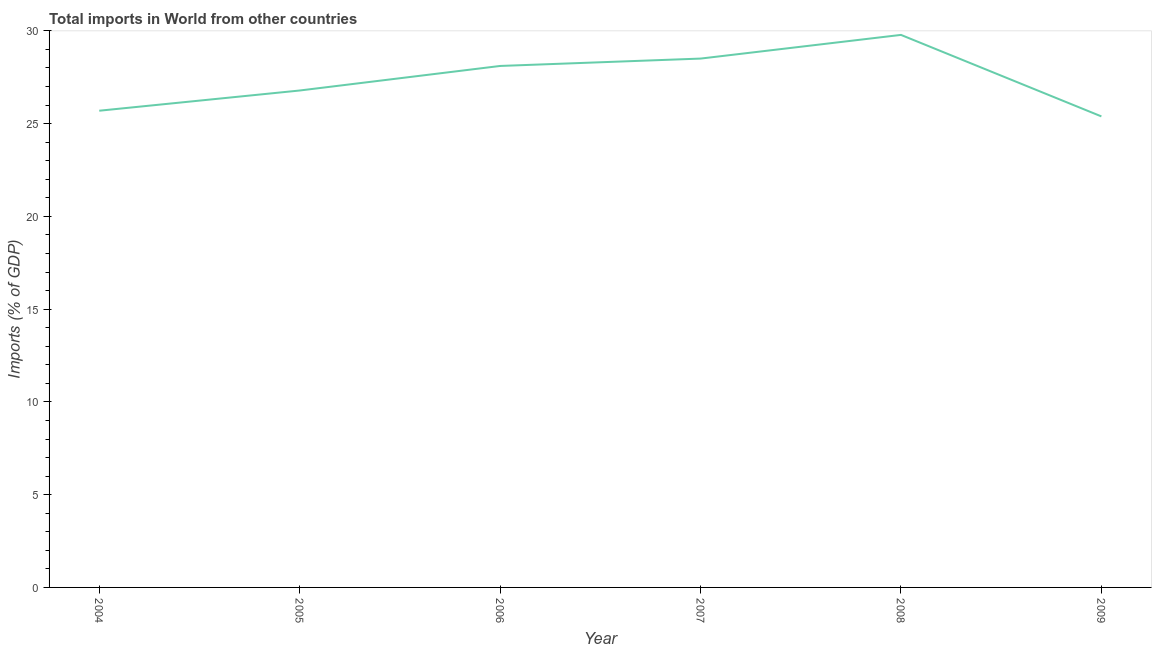What is the total imports in 2007?
Your response must be concise. 28.5. Across all years, what is the maximum total imports?
Your response must be concise. 29.78. Across all years, what is the minimum total imports?
Give a very brief answer. 25.39. In which year was the total imports minimum?
Keep it short and to the point. 2009. What is the sum of the total imports?
Make the answer very short. 164.26. What is the difference between the total imports in 2007 and 2009?
Give a very brief answer. 3.12. What is the average total imports per year?
Make the answer very short. 27.38. What is the median total imports?
Ensure brevity in your answer.  27.45. In how many years, is the total imports greater than 4 %?
Keep it short and to the point. 6. Do a majority of the years between 2007 and 2008 (inclusive) have total imports greater than 16 %?
Ensure brevity in your answer.  Yes. What is the ratio of the total imports in 2006 to that in 2008?
Your answer should be very brief. 0.94. Is the total imports in 2004 less than that in 2009?
Offer a very short reply. No. Is the difference between the total imports in 2004 and 2007 greater than the difference between any two years?
Your answer should be very brief. No. What is the difference between the highest and the second highest total imports?
Keep it short and to the point. 1.28. What is the difference between the highest and the lowest total imports?
Make the answer very short. 4.39. In how many years, is the total imports greater than the average total imports taken over all years?
Your answer should be compact. 3. How many years are there in the graph?
Provide a short and direct response. 6. Does the graph contain any zero values?
Keep it short and to the point. No. What is the title of the graph?
Keep it short and to the point. Total imports in World from other countries. What is the label or title of the X-axis?
Provide a short and direct response. Year. What is the label or title of the Y-axis?
Provide a short and direct response. Imports (% of GDP). What is the Imports (% of GDP) of 2004?
Provide a succinct answer. 25.69. What is the Imports (% of GDP) of 2005?
Give a very brief answer. 26.78. What is the Imports (% of GDP) in 2006?
Offer a very short reply. 28.11. What is the Imports (% of GDP) of 2007?
Offer a terse response. 28.5. What is the Imports (% of GDP) in 2008?
Keep it short and to the point. 29.78. What is the Imports (% of GDP) in 2009?
Ensure brevity in your answer.  25.39. What is the difference between the Imports (% of GDP) in 2004 and 2005?
Provide a short and direct response. -1.09. What is the difference between the Imports (% of GDP) in 2004 and 2006?
Offer a terse response. -2.41. What is the difference between the Imports (% of GDP) in 2004 and 2007?
Give a very brief answer. -2.81. What is the difference between the Imports (% of GDP) in 2004 and 2008?
Offer a very short reply. -4.09. What is the difference between the Imports (% of GDP) in 2004 and 2009?
Offer a terse response. 0.31. What is the difference between the Imports (% of GDP) in 2005 and 2006?
Your response must be concise. -1.32. What is the difference between the Imports (% of GDP) in 2005 and 2007?
Make the answer very short. -1.72. What is the difference between the Imports (% of GDP) in 2005 and 2008?
Offer a terse response. -3. What is the difference between the Imports (% of GDP) in 2005 and 2009?
Your response must be concise. 1.4. What is the difference between the Imports (% of GDP) in 2006 and 2007?
Give a very brief answer. -0.4. What is the difference between the Imports (% of GDP) in 2006 and 2008?
Your answer should be very brief. -1.67. What is the difference between the Imports (% of GDP) in 2006 and 2009?
Your response must be concise. 2.72. What is the difference between the Imports (% of GDP) in 2007 and 2008?
Give a very brief answer. -1.28. What is the difference between the Imports (% of GDP) in 2007 and 2009?
Offer a terse response. 3.12. What is the difference between the Imports (% of GDP) in 2008 and 2009?
Give a very brief answer. 4.39. What is the ratio of the Imports (% of GDP) in 2004 to that in 2006?
Give a very brief answer. 0.91. What is the ratio of the Imports (% of GDP) in 2004 to that in 2007?
Your answer should be compact. 0.9. What is the ratio of the Imports (% of GDP) in 2004 to that in 2008?
Your answer should be compact. 0.86. What is the ratio of the Imports (% of GDP) in 2005 to that in 2006?
Make the answer very short. 0.95. What is the ratio of the Imports (% of GDP) in 2005 to that in 2008?
Provide a short and direct response. 0.9. What is the ratio of the Imports (% of GDP) in 2005 to that in 2009?
Your answer should be compact. 1.05. What is the ratio of the Imports (% of GDP) in 2006 to that in 2008?
Keep it short and to the point. 0.94. What is the ratio of the Imports (% of GDP) in 2006 to that in 2009?
Offer a terse response. 1.11. What is the ratio of the Imports (% of GDP) in 2007 to that in 2009?
Provide a short and direct response. 1.12. What is the ratio of the Imports (% of GDP) in 2008 to that in 2009?
Offer a terse response. 1.17. 